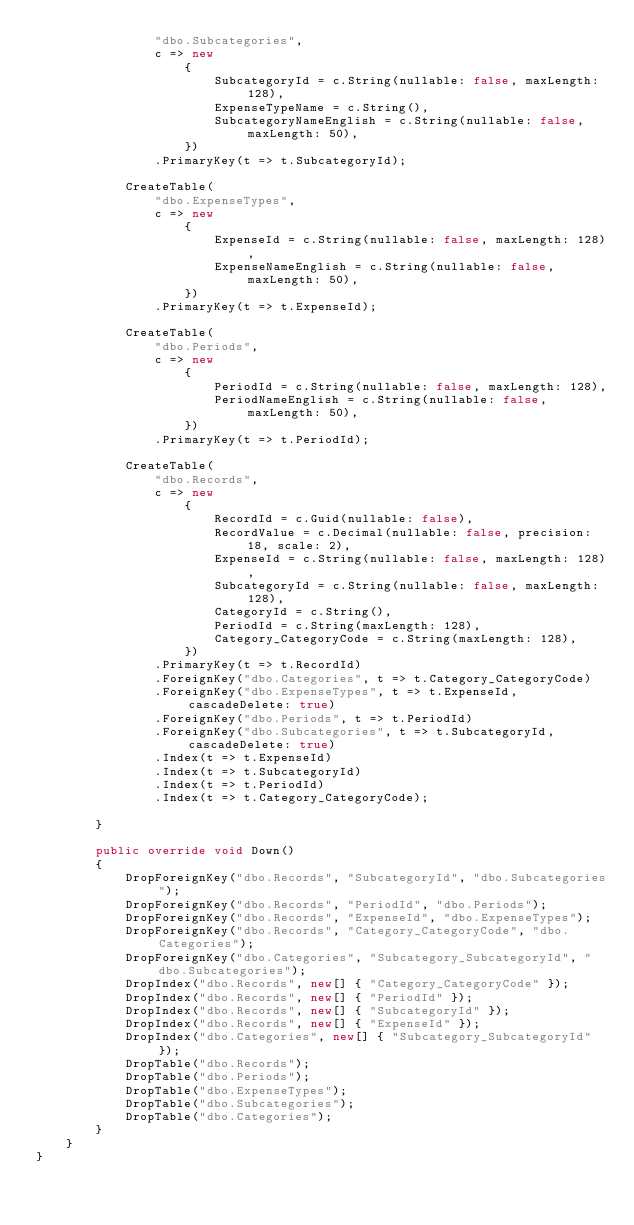Convert code to text. <code><loc_0><loc_0><loc_500><loc_500><_C#_>                "dbo.Subcategories",
                c => new
                    {
                        SubcategoryId = c.String(nullable: false, maxLength: 128),
                        ExpenseTypeName = c.String(),
                        SubcategoryNameEnglish = c.String(nullable: false, maxLength: 50),
                    })
                .PrimaryKey(t => t.SubcategoryId);
            
            CreateTable(
                "dbo.ExpenseTypes",
                c => new
                    {
                        ExpenseId = c.String(nullable: false, maxLength: 128),
                        ExpenseNameEnglish = c.String(nullable: false, maxLength: 50),
                    })
                .PrimaryKey(t => t.ExpenseId);
            
            CreateTable(
                "dbo.Periods",
                c => new
                    {
                        PeriodId = c.String(nullable: false, maxLength: 128),
                        PeriodNameEnglish = c.String(nullable: false, maxLength: 50),
                    })
                .PrimaryKey(t => t.PeriodId);
            
            CreateTable(
                "dbo.Records",
                c => new
                    {
                        RecordId = c.Guid(nullable: false),
                        RecordValue = c.Decimal(nullable: false, precision: 18, scale: 2),
                        ExpenseId = c.String(nullable: false, maxLength: 128),
                        SubcategoryId = c.String(nullable: false, maxLength: 128),
                        CategoryId = c.String(),
                        PeriodId = c.String(maxLength: 128),
                        Category_CategoryCode = c.String(maxLength: 128),
                    })
                .PrimaryKey(t => t.RecordId)
                .ForeignKey("dbo.Categories", t => t.Category_CategoryCode)
                .ForeignKey("dbo.ExpenseTypes", t => t.ExpenseId, cascadeDelete: true)
                .ForeignKey("dbo.Periods", t => t.PeriodId)
                .ForeignKey("dbo.Subcategories", t => t.SubcategoryId, cascadeDelete: true)
                .Index(t => t.ExpenseId)
                .Index(t => t.SubcategoryId)
                .Index(t => t.PeriodId)
                .Index(t => t.Category_CategoryCode);
            
        }
        
        public override void Down()
        {
            DropForeignKey("dbo.Records", "SubcategoryId", "dbo.Subcategories");
            DropForeignKey("dbo.Records", "PeriodId", "dbo.Periods");
            DropForeignKey("dbo.Records", "ExpenseId", "dbo.ExpenseTypes");
            DropForeignKey("dbo.Records", "Category_CategoryCode", "dbo.Categories");
            DropForeignKey("dbo.Categories", "Subcategory_SubcategoryId", "dbo.Subcategories");
            DropIndex("dbo.Records", new[] { "Category_CategoryCode" });
            DropIndex("dbo.Records", new[] { "PeriodId" });
            DropIndex("dbo.Records", new[] { "SubcategoryId" });
            DropIndex("dbo.Records", new[] { "ExpenseId" });
            DropIndex("dbo.Categories", new[] { "Subcategory_SubcategoryId" });
            DropTable("dbo.Records");
            DropTable("dbo.Periods");
            DropTable("dbo.ExpenseTypes");
            DropTable("dbo.Subcategories");
            DropTable("dbo.Categories");
        }
    }
}
</code> 